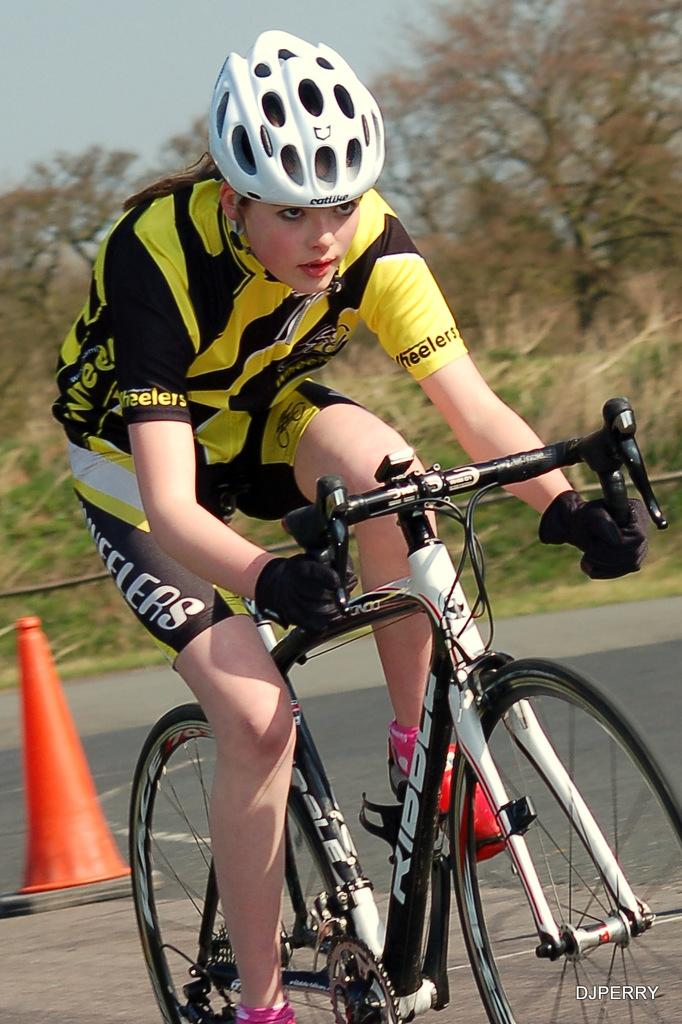Who is in the image? There is a woman in the image. What is the woman doing in the image? The woman is sitting and riding a bicycle. What safety precaution is the woman taking while riding the bicycle? The woman is wearing a helmet. What can be seen on the road in the image? There is a traffic cone on the road. What is visible in the background of the image? There are trees and the sky visible in the background of the image. What type of pollution can be seen in the image? There is no visible pollution in the image. How many arms does the woman have in the image? The image does not show the woman's arms, so it cannot be determined how many arms she has. 